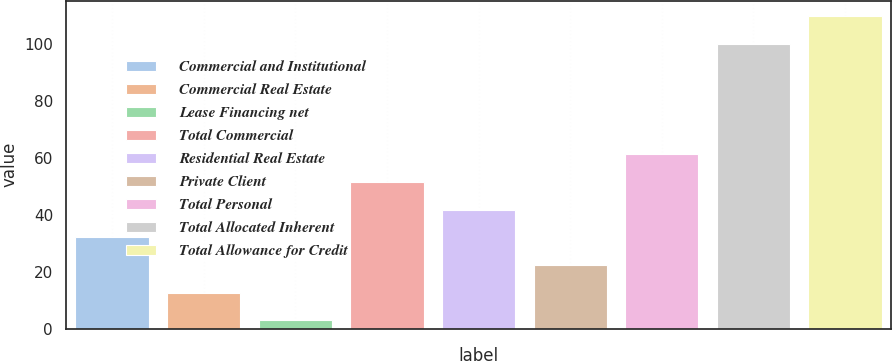<chart> <loc_0><loc_0><loc_500><loc_500><bar_chart><fcel>Commercial and Institutional<fcel>Commercial Real Estate<fcel>Lease Financing net<fcel>Total Commercial<fcel>Residential Real Estate<fcel>Private Client<fcel>Total Personal<fcel>Total Allocated Inherent<fcel>Total Allowance for Credit<nl><fcel>32.1<fcel>12.7<fcel>3<fcel>51.5<fcel>41.8<fcel>22.4<fcel>61.2<fcel>100<fcel>109.7<nl></chart> 